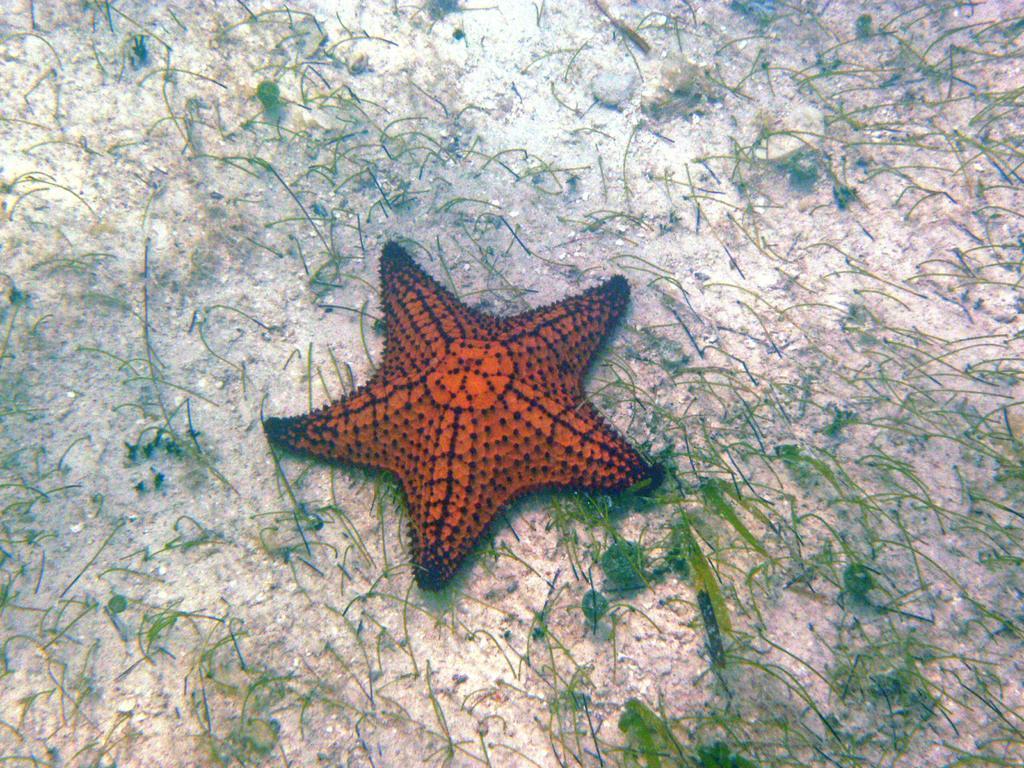Please provide a concise description of this image. In this image we can see the starfish, grass and also the sand in the water. 